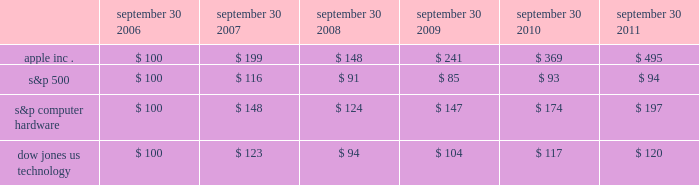Company stock performance the following graph shows a five-year comparison of cumulative total shareholder return , calculated on a dividend reinvested basis , for the company , the s&p 500 composite index , the s&p computer hardware index , and the dow jones u.s .
Technology index .
The graph assumes $ 100 was invested in each of the company 2019s common stock , the s&p 500 composite index , the s&p computer hardware index , and the dow jones u.s .
Technology index on september 30 , 2006 .
Data points on the graph are annual .
Note that historic stock price performance is not necessarily indicative of future stock price performance .
Comparison of 5 year cumulative total return* among apple inc. , the s&p 500 index , the s&p computer hardware index and the dow jones us technology index sep-10sep-09sep-08sep-07sep-06 sep-11 apple inc .
S&p 500 s&p computer hardware dow jones us technology *$ 100 invested on 9/30/06 in stock or index , including reinvestment of dividends .
Fiscal year ending september 30 .
Copyright a9 2011 s&p , a division of the mcgraw-hill companies inc .
All rights reserved .
Copyright a9 2011 dow jones & co .
All rights reserved .
September 30 , september 30 , september 30 , september 30 , september 30 , september 30 .

What was the cumulative percentage return for the five years ended september 30 , 2011 for apple inc.? 
Computations: ((495 - 100) / 100)
Answer: 3.95. 